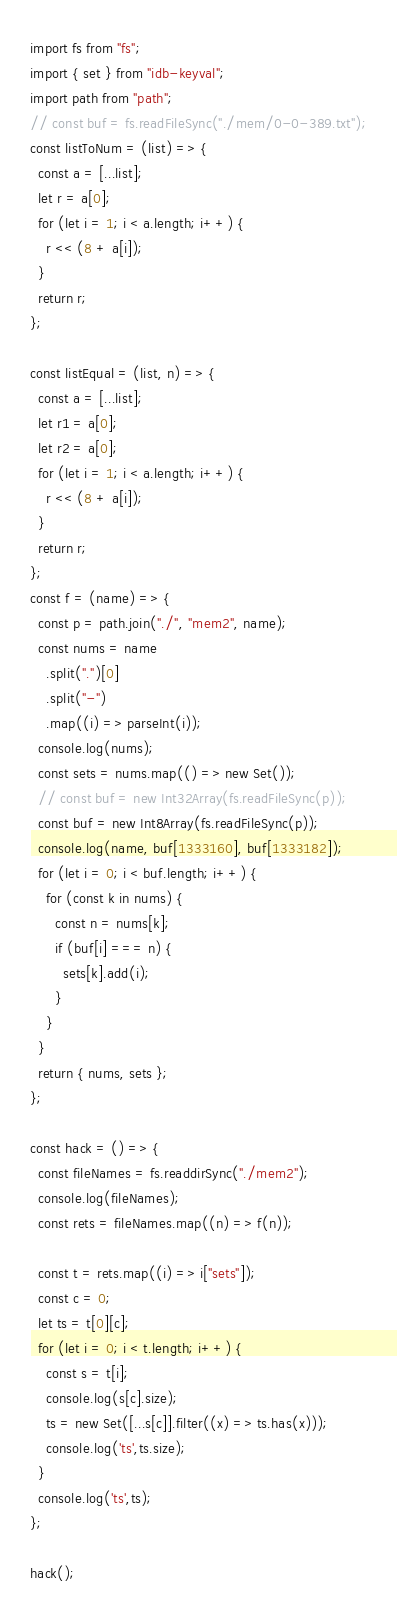<code> <loc_0><loc_0><loc_500><loc_500><_JavaScript_>import fs from "fs";
import { set } from "idb-keyval";
import path from "path";
// const buf = fs.readFileSync("./mem/0-0-389.txt");
const listToNum = (list) => {
  const a = [...list];
  let r = a[0];
  for (let i = 1; i < a.length; i++) {
    r << (8 + a[i]);
  }
  return r;
};

const listEqual = (list, n) => {
  const a = [...list];
  let r1 = a[0];
  let r2 = a[0];
  for (let i = 1; i < a.length; i++) {
    r << (8 + a[i]);
  }
  return r;
};
const f = (name) => {
  const p = path.join("./", "mem2", name);
  const nums = name
    .split(".")[0]
    .split("-")
    .map((i) => parseInt(i));
  console.log(nums);
  const sets = nums.map(() => new Set());
  // const buf = new Int32Array(fs.readFileSync(p));
  const buf = new Int8Array(fs.readFileSync(p));
  console.log(name, buf[1333160], buf[1333182]);
  for (let i = 0; i < buf.length; i++) {
    for (const k in nums) {
      const n = nums[k];
      if (buf[i] === n) {
        sets[k].add(i);
      }
    }
  }
  return { nums, sets };
};

const hack = () => {
  const fileNames = fs.readdirSync("./mem2");
  console.log(fileNames);
  const rets = fileNames.map((n) => f(n));

  const t = rets.map((i) => i["sets"]);
  const c = 0;
  let ts = t[0][c];
  for (let i = 0; i < t.length; i++) {
    const s = t[i];
    console.log(s[c].size);
    ts = new Set([...s[c]].filter((x) => ts.has(x)));
    console.log('ts',ts.size);
  }
  console.log('ts',ts);
};

hack();
</code> 